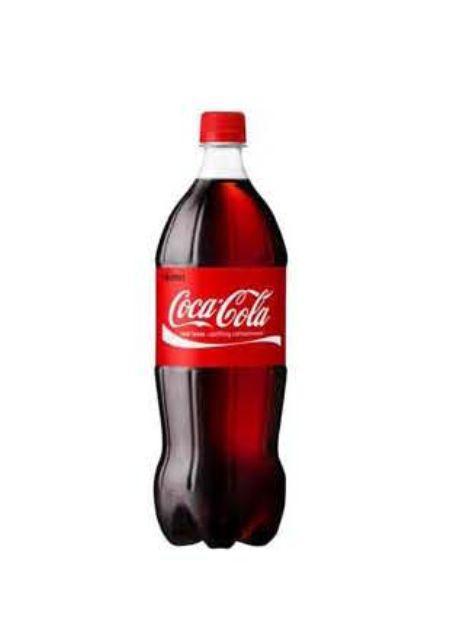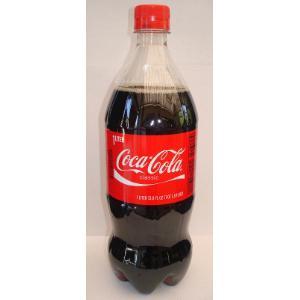The first image is the image on the left, the second image is the image on the right. For the images shown, is this caption "The right image contains at least three bottles." true? Answer yes or no. No. The first image is the image on the left, the second image is the image on the right. For the images shown, is this caption "The left image includes three varieties of one brand of soda in transparent plastic bottles, which are in a row but not touching." true? Answer yes or no. No. 